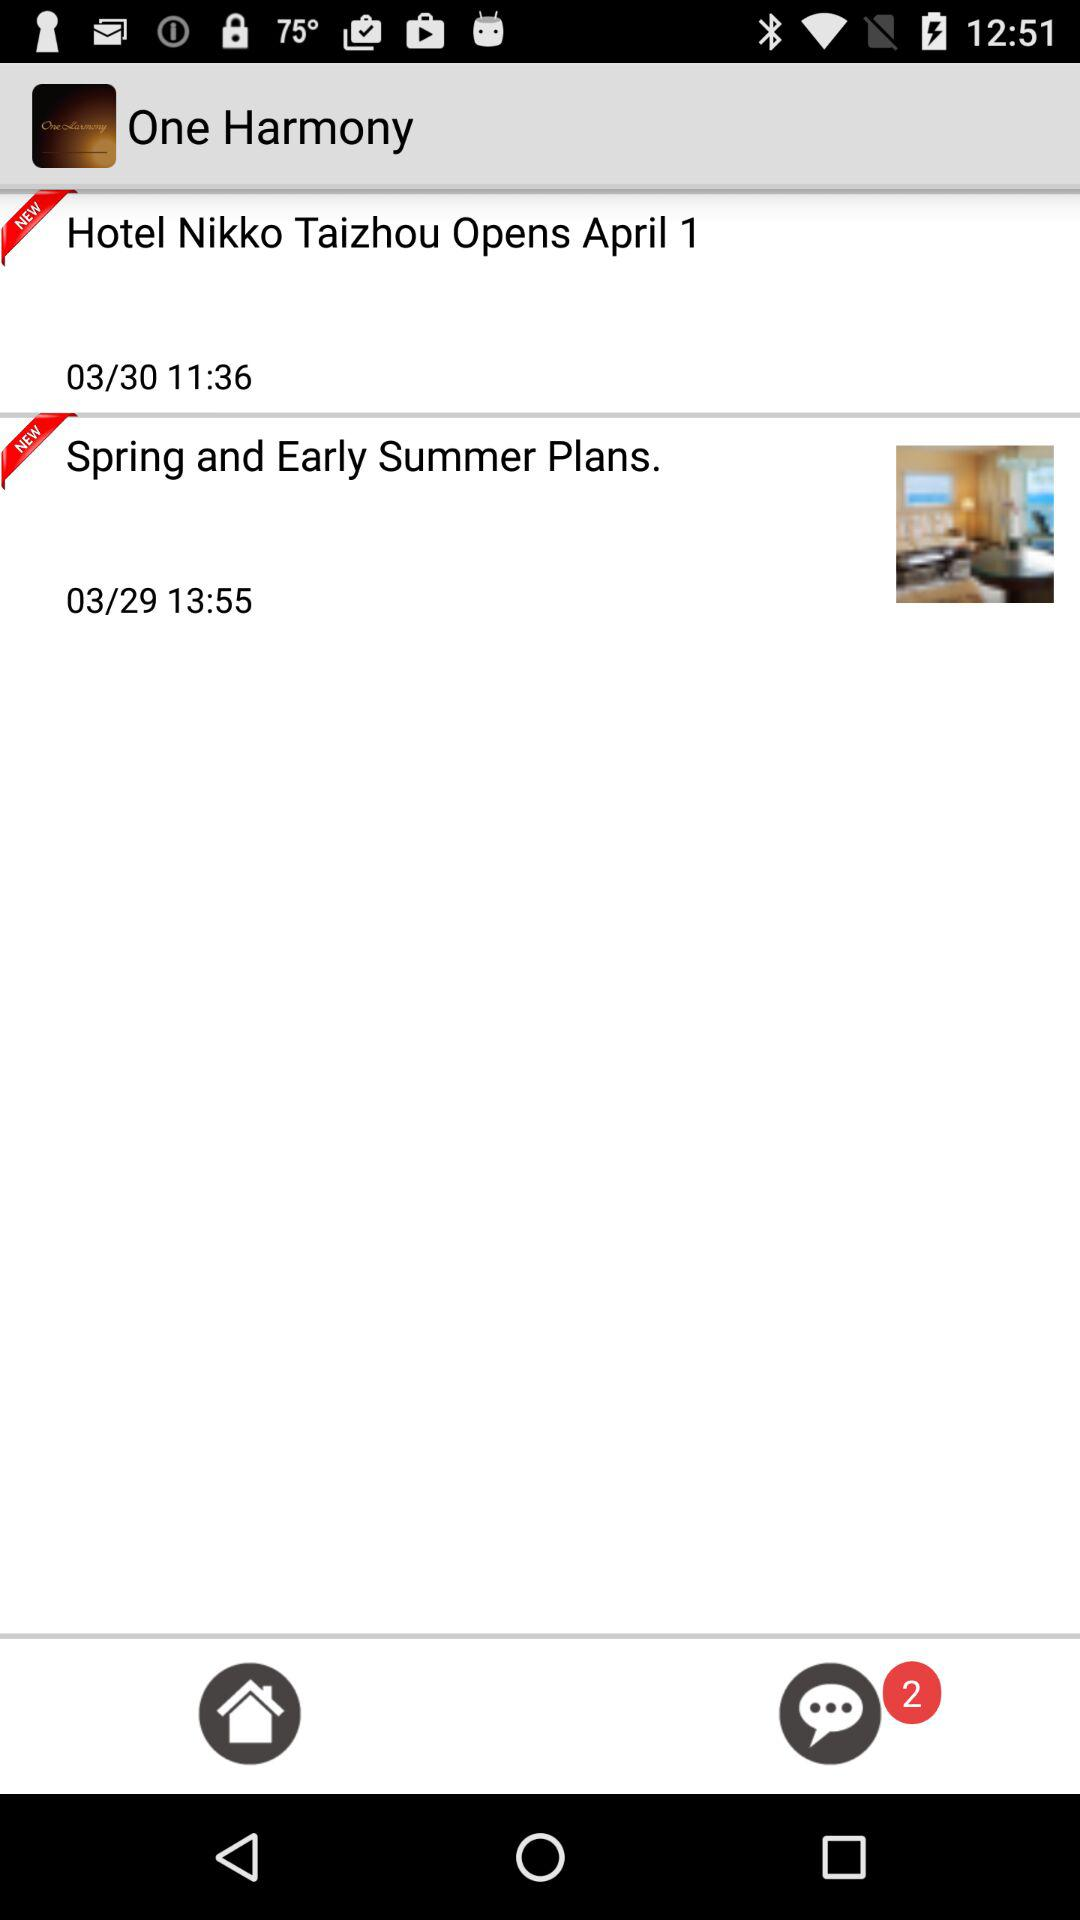How many unread comments are there? There are 2 unread comments. 